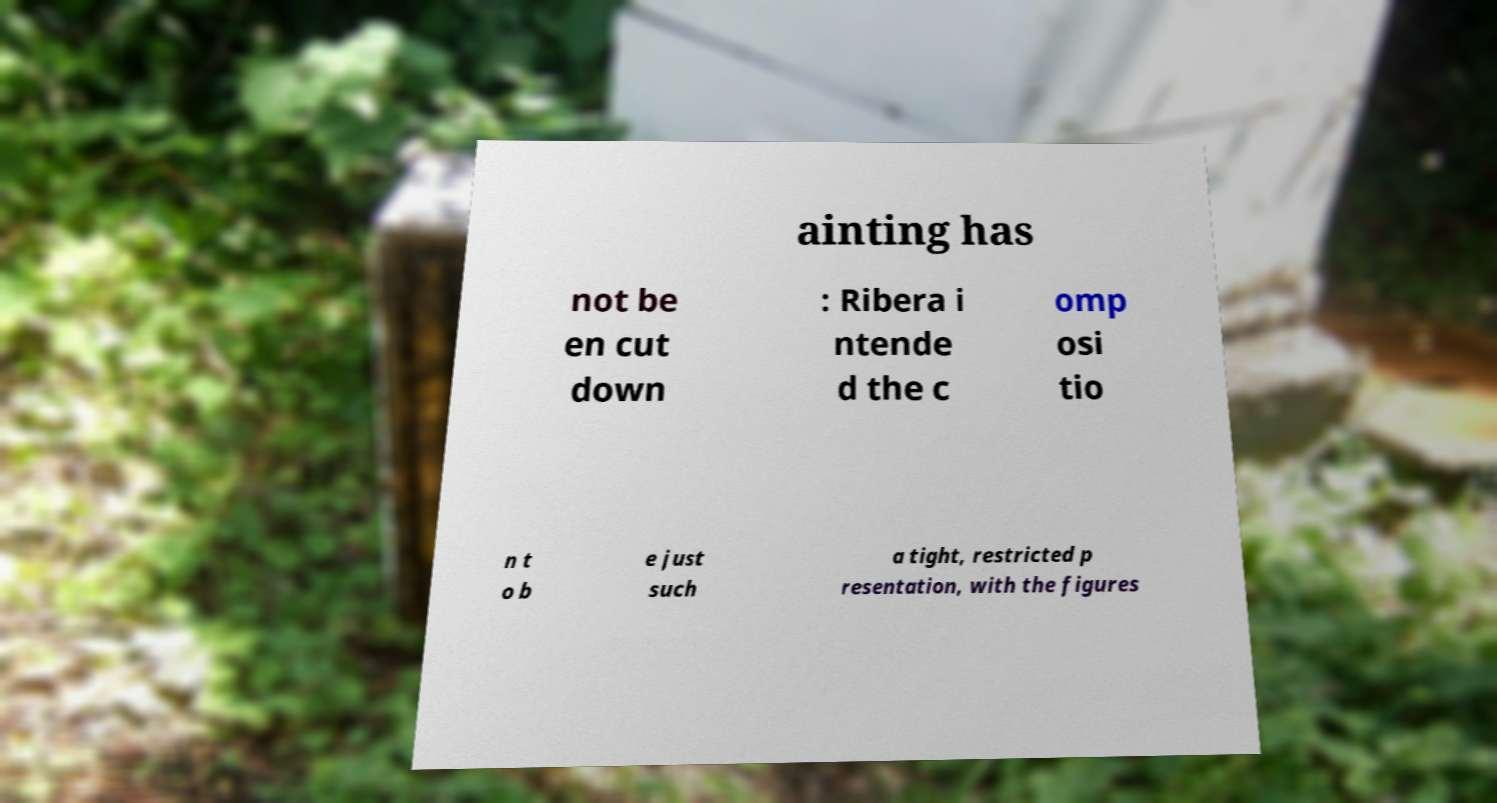Please read and relay the text visible in this image. What does it say? ainting has not be en cut down : Ribera i ntende d the c omp osi tio n t o b e just such a tight, restricted p resentation, with the figures 